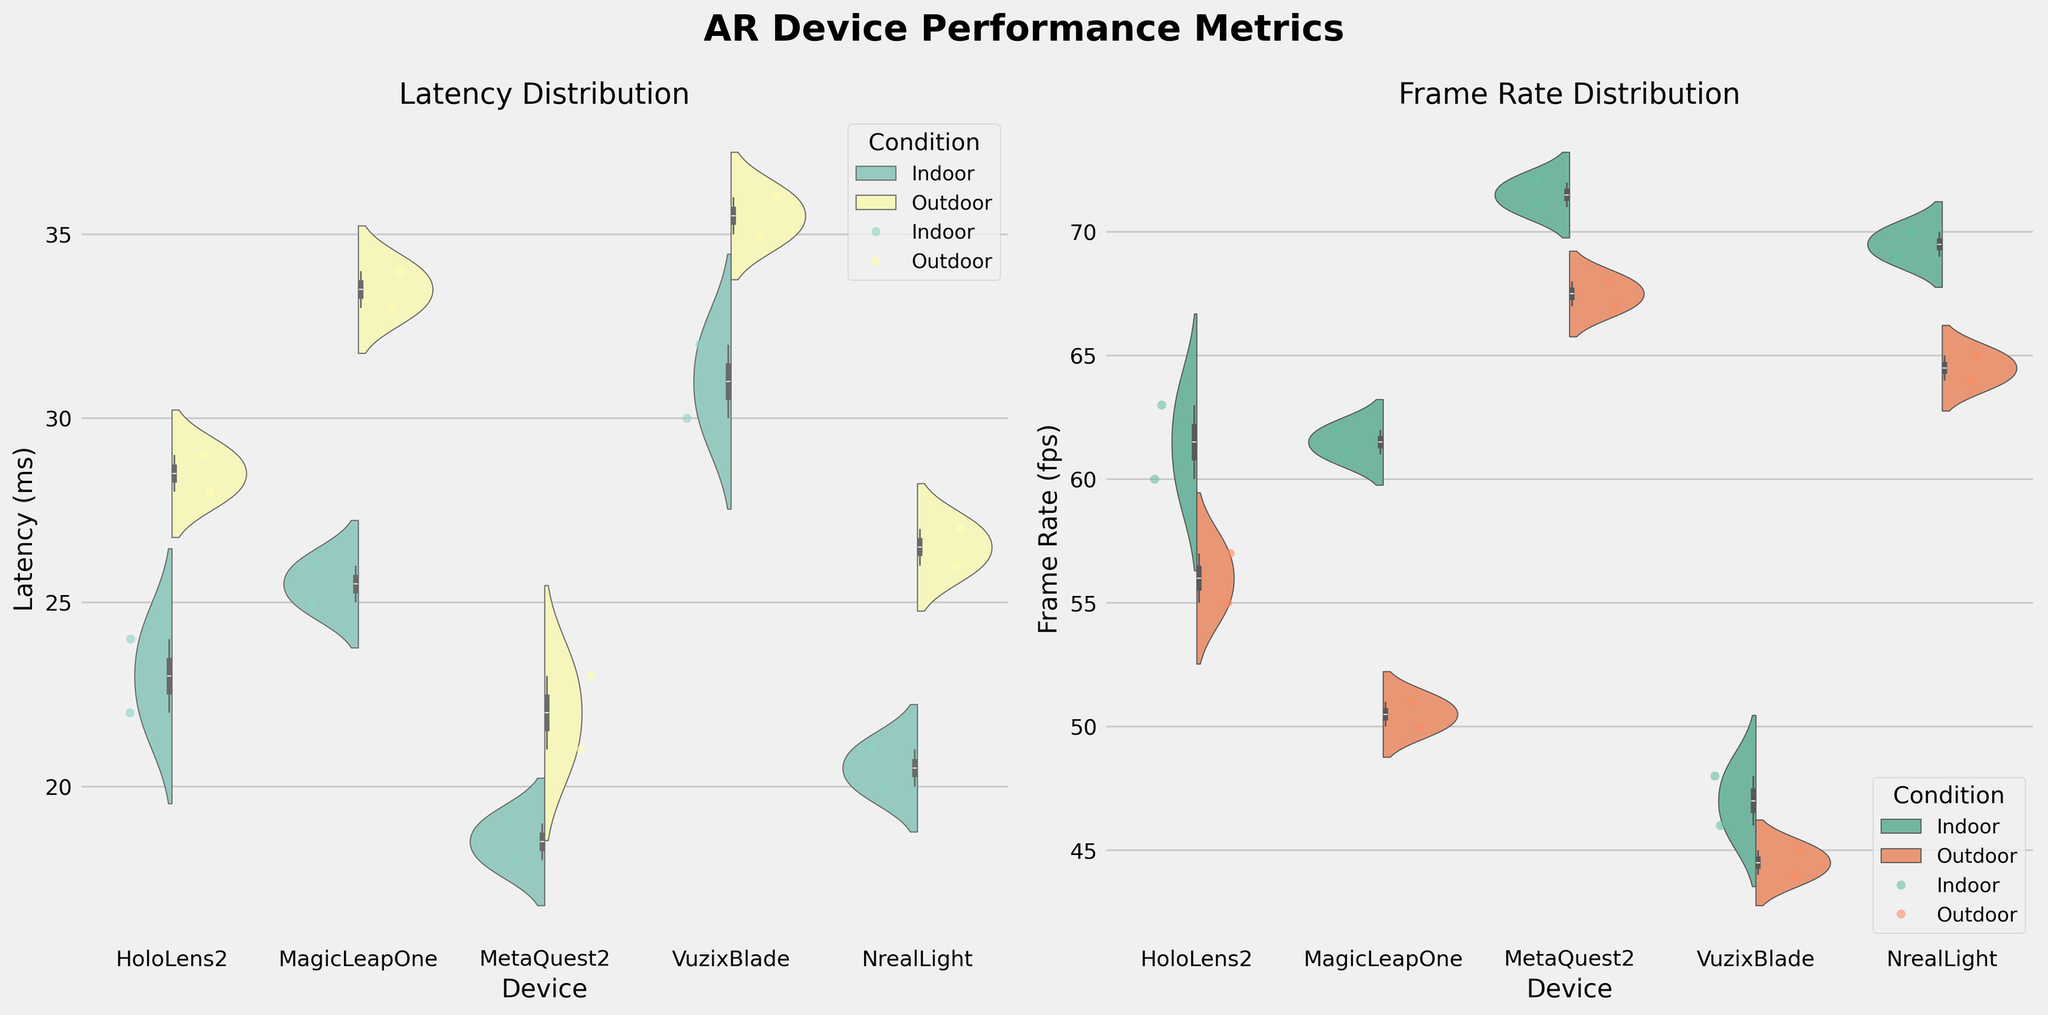What are the titles of the two individual subplots? The titles of the subplots are presented at the top of each subplot. The left subplot is titled "Latency Distribution" and the right subplot is titled "Frame Rate Distribution".
Answer: Latency Distribution, Frame Rate Distribution Which AR device shows the highest median latency in outdoor conditions? By observing the median line within the violin plots for the outdoor condition, the VuzixBlade shows the highest median latency compared to other devices.
Answer: VuzixBlade How do the indoor and outdoor latency distributions compare for the MetaQuest2? The violin plot for MetaQuest2 indicates lower latency for indoor conditions, whereas the latency for outdoor conditions is slightly higher. This can be seen from the spread and median of the data points for each condition.
Answer: Indoor latency is lower, Outdoor latency is higher Which device demonstrates the widest range of frame rates in indoor conditions? By looking at the spread of the data within the violin plots for indoor conditions, the NrealLight demonstrates the widest range of frame rates compared to other devices.
Answer: NrealLight What can be inferred about the overall latency performance in indoor vs. outdoor conditions? From the side-by-side comparison of the violin plots, it's clear that latencies generally tend to be lower in indoor conditions and higher in outdoor conditions across most devices. This is evident from the higher spread and medians in the outdoor condition plots.
Answer: Latency is generally lower indoors and higher outdoors How does the frame rate of the MagicLeapOne compare between indoor and outdoor conditions? The violin plots show that the MagicLeapOne has a higher frame rate in indoor conditions compared to outdoor conditions, indicated by higher median and tight distribution of points in the indoor plot.
Answer: Higher indoors, lower outdoors Which device shows the smallest difference in median latency between indoor and outdoor conditions? By comparing the median lines in the violin plots, the MetaQuest2 exhibits the smallest difference in median latency between indoor and outdoor conditions.
Answer: MetaQuest2 How do the latency values for NrealLight under outdoor conditions compare to those under indoor conditions? The violin plots for NrealLight show that latency values are higher under outdoor conditions compared to indoor conditions. This is visible from the higher spread and median in the outdoor plot.
Answer: Higher outdoors, lower indoors Among the devices, which one has the highest frame rate in the indoor condition? From examining the violin plots, the MetaQuest2 has the highest frame rate in the indoor condition, visible from the higher spread and median in the plot.
Answer: MetaQuest2 